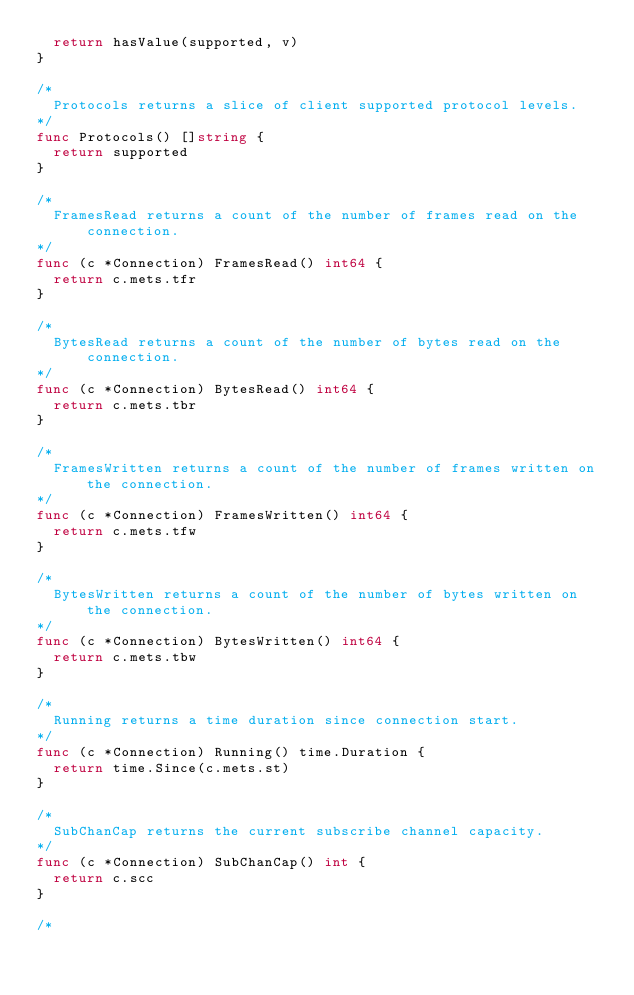Convert code to text. <code><loc_0><loc_0><loc_500><loc_500><_Go_>	return hasValue(supported, v)
}

/*
	Protocols returns a slice of client supported protocol levels.
*/
func Protocols() []string {
	return supported
}

/*
	FramesRead returns a count of the number of frames read on the connection.
*/
func (c *Connection) FramesRead() int64 {
	return c.mets.tfr
}

/*
	BytesRead returns a count of the number of bytes read on the connection.
*/
func (c *Connection) BytesRead() int64 {
	return c.mets.tbr
}

/*
	FramesWritten returns a count of the number of frames written on the connection.
*/
func (c *Connection) FramesWritten() int64 {
	return c.mets.tfw
}

/*
	BytesWritten returns a count of the number of bytes written on the connection.
*/
func (c *Connection) BytesWritten() int64 {
	return c.mets.tbw
}

/*
	Running returns a time duration since connection start.
*/
func (c *Connection) Running() time.Duration {
	return time.Since(c.mets.st)
}

/*
	SubChanCap returns the current subscribe channel capacity.
*/
func (c *Connection) SubChanCap() int {
	return c.scc
}

/*</code> 